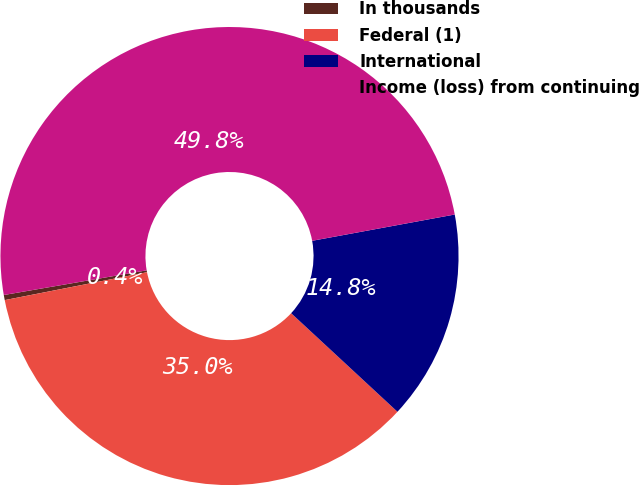Convert chart. <chart><loc_0><loc_0><loc_500><loc_500><pie_chart><fcel>In thousands<fcel>Federal (1)<fcel>International<fcel>Income (loss) from continuing<nl><fcel>0.36%<fcel>35.02%<fcel>14.8%<fcel>49.82%<nl></chart> 